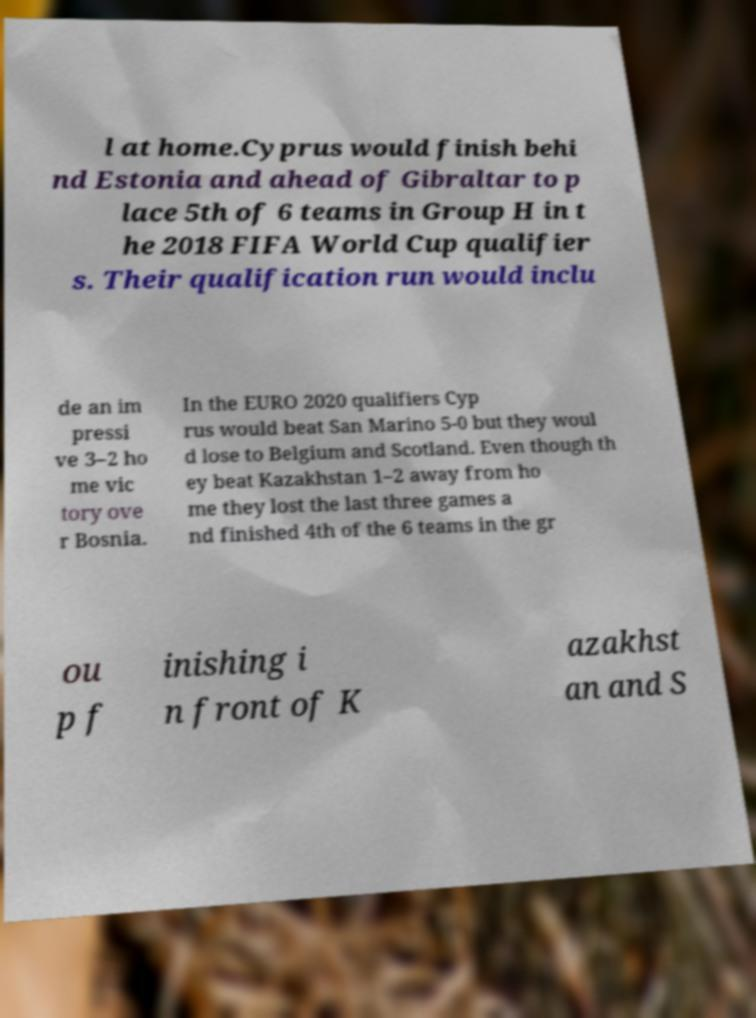I need the written content from this picture converted into text. Can you do that? l at home.Cyprus would finish behi nd Estonia and ahead of Gibraltar to p lace 5th of 6 teams in Group H in t he 2018 FIFA World Cup qualifier s. Their qualification run would inclu de an im pressi ve 3–2 ho me vic tory ove r Bosnia. In the EURO 2020 qualifiers Cyp rus would beat San Marino 5-0 but they woul d lose to Belgium and Scotland. Even though th ey beat Kazakhstan 1–2 away from ho me they lost the last three games a nd finished 4th of the 6 teams in the gr ou p f inishing i n front of K azakhst an and S 